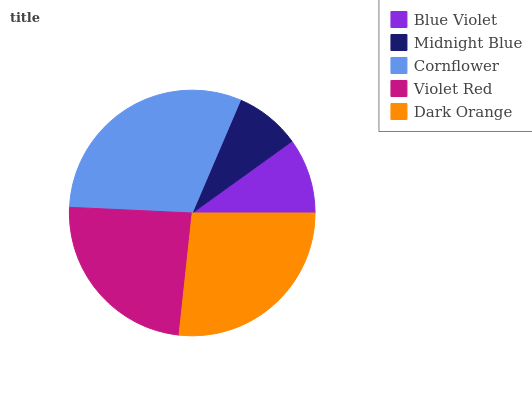Is Midnight Blue the minimum?
Answer yes or no. Yes. Is Cornflower the maximum?
Answer yes or no. Yes. Is Cornflower the minimum?
Answer yes or no. No. Is Midnight Blue the maximum?
Answer yes or no. No. Is Cornflower greater than Midnight Blue?
Answer yes or no. Yes. Is Midnight Blue less than Cornflower?
Answer yes or no. Yes. Is Midnight Blue greater than Cornflower?
Answer yes or no. No. Is Cornflower less than Midnight Blue?
Answer yes or no. No. Is Violet Red the high median?
Answer yes or no. Yes. Is Violet Red the low median?
Answer yes or no. Yes. Is Cornflower the high median?
Answer yes or no. No. Is Midnight Blue the low median?
Answer yes or no. No. 